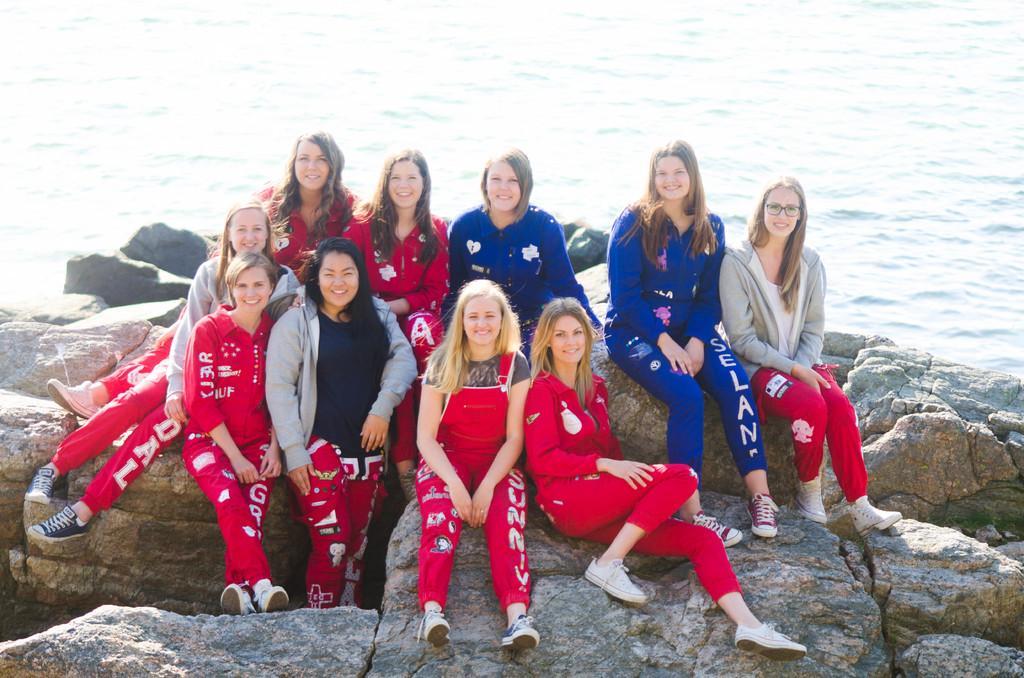In one or two sentences, can you explain what this image depicts? In this image I can see number of women are sitting and I can see all of them are smiling. I can also see three of them are wearing jackets, two of them are wearing blue colour dress and rest all are wearing red colour dress. I can also see number of stones and in the background I can see water. 